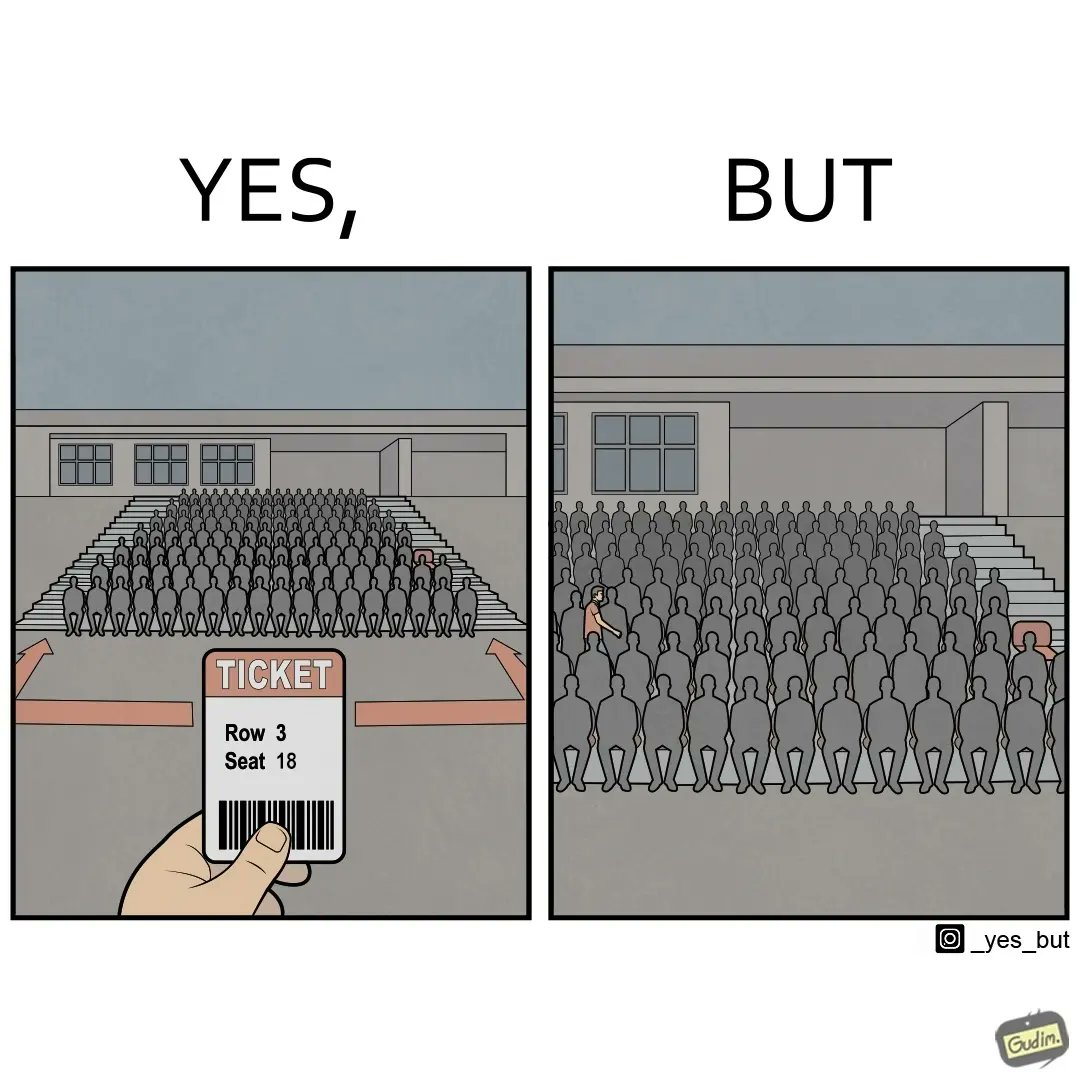What do you see in each half of this image? In the left part of the image: image shows a gallery of seats. Someone is holding a ticket for the seat in Row 3, Seat 18, which is vacant. In the right part of the image: a person walking through the 3rd row of gallery seats filled with audience to get to the 18th seat in the row, which is vacant. 